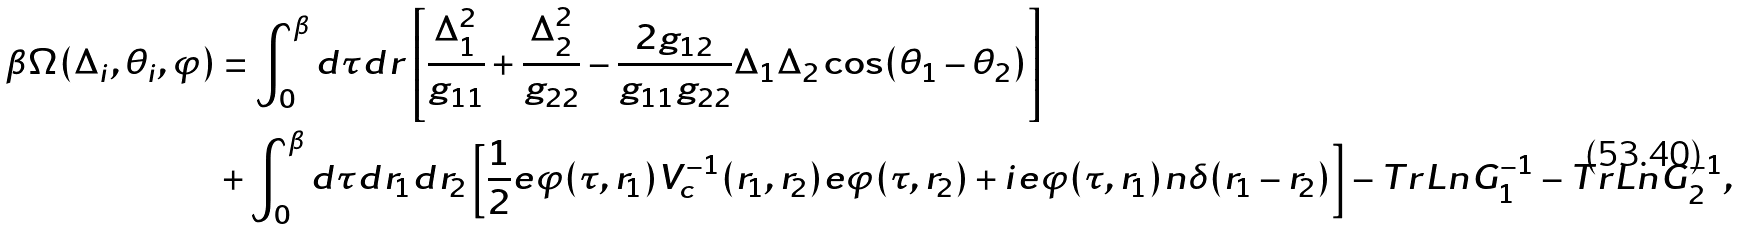Convert formula to latex. <formula><loc_0><loc_0><loc_500><loc_500>\beta \Omega ( \Delta _ { i } , \theta _ { i } , \varphi ) & = \int _ { 0 } ^ { \beta } d \tau d r \left [ \frac { \Delta _ { 1 } ^ { 2 } } { g _ { 1 1 } } + \frac { \Delta _ { 2 } ^ { 2 } } { g _ { 2 2 } } - \frac { 2 g _ { 1 2 } } { g _ { 1 1 } g _ { 2 2 } } \Delta _ { 1 } \Delta _ { 2 } \cos ( \theta _ { 1 } - \theta _ { 2 } ) \right ] \\ & + \int _ { 0 } ^ { \beta } d \tau d r _ { 1 } d r _ { 2 } \left [ \frac { 1 } { 2 } e \varphi ( \tau , r _ { 1 } ) V _ { c } ^ { - 1 } ( r _ { 1 } , r _ { 2 } ) e \varphi ( \tau , r _ { 2 } ) + i e \varphi ( \tau , r _ { 1 } ) n \delta ( r _ { 1 } - r _ { 2 } ) \right ] - T r L n G _ { 1 } ^ { - 1 } - T r L n G _ { 2 } ^ { - 1 } ,</formula> 